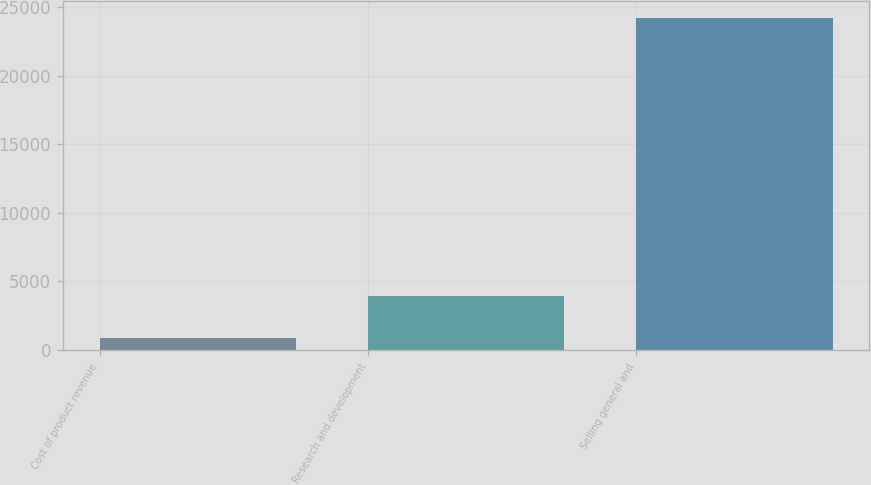Convert chart to OTSL. <chart><loc_0><loc_0><loc_500><loc_500><bar_chart><fcel>Cost of product revenue<fcel>Research and development<fcel>Selling general and<nl><fcel>895<fcel>3950<fcel>24208<nl></chart> 